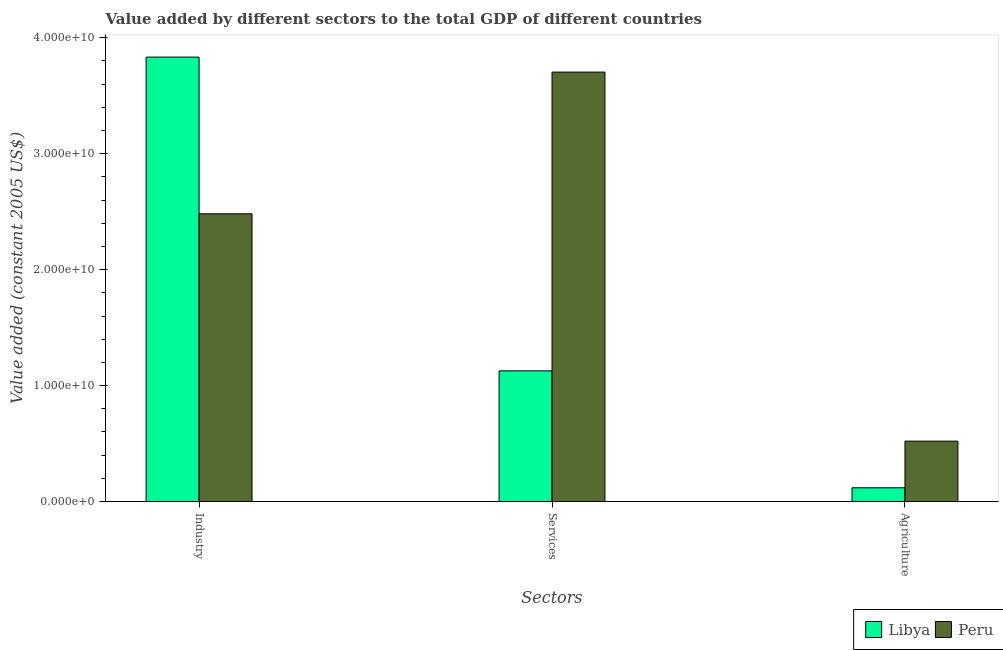Are the number of bars on each tick of the X-axis equal?
Offer a very short reply. Yes. How many bars are there on the 2nd tick from the left?
Ensure brevity in your answer.  2. How many bars are there on the 2nd tick from the right?
Provide a short and direct response. 2. What is the label of the 1st group of bars from the left?
Offer a terse response. Industry. What is the value added by industrial sector in Peru?
Your answer should be very brief. 2.48e+1. Across all countries, what is the maximum value added by agricultural sector?
Provide a succinct answer. 5.21e+09. Across all countries, what is the minimum value added by industrial sector?
Your answer should be very brief. 2.48e+1. In which country was the value added by agricultural sector minimum?
Ensure brevity in your answer.  Libya. What is the total value added by agricultural sector in the graph?
Give a very brief answer. 6.40e+09. What is the difference between the value added by services in Peru and that in Libya?
Provide a short and direct response. 2.58e+1. What is the difference between the value added by agricultural sector in Libya and the value added by services in Peru?
Make the answer very short. -3.58e+1. What is the average value added by services per country?
Make the answer very short. 2.42e+1. What is the difference between the value added by services and value added by agricultural sector in Peru?
Give a very brief answer. 3.18e+1. In how many countries, is the value added by industrial sector greater than 32000000000 US$?
Offer a very short reply. 1. What is the ratio of the value added by industrial sector in Peru to that in Libya?
Your response must be concise. 0.65. Is the value added by services in Libya less than that in Peru?
Offer a very short reply. Yes. What is the difference between the highest and the second highest value added by services?
Offer a terse response. 2.58e+1. What is the difference between the highest and the lowest value added by agricultural sector?
Your answer should be compact. 4.02e+09. Is the sum of the value added by agricultural sector in Peru and Libya greater than the maximum value added by services across all countries?
Provide a succinct answer. No. What does the 1st bar from the left in Services represents?
Offer a terse response. Libya. What does the 2nd bar from the right in Services represents?
Your answer should be very brief. Libya. Is it the case that in every country, the sum of the value added by industrial sector and value added by services is greater than the value added by agricultural sector?
Your answer should be compact. Yes. Are all the bars in the graph horizontal?
Offer a very short reply. No. Where does the legend appear in the graph?
Provide a short and direct response. Bottom right. How many legend labels are there?
Provide a succinct answer. 2. How are the legend labels stacked?
Your response must be concise. Horizontal. What is the title of the graph?
Your answer should be very brief. Value added by different sectors to the total GDP of different countries. What is the label or title of the X-axis?
Offer a terse response. Sectors. What is the label or title of the Y-axis?
Provide a succinct answer. Value added (constant 2005 US$). What is the Value added (constant 2005 US$) in Libya in Industry?
Give a very brief answer. 3.83e+1. What is the Value added (constant 2005 US$) of Peru in Industry?
Your response must be concise. 2.48e+1. What is the Value added (constant 2005 US$) of Libya in Services?
Ensure brevity in your answer.  1.13e+1. What is the Value added (constant 2005 US$) of Peru in Services?
Keep it short and to the point. 3.70e+1. What is the Value added (constant 2005 US$) of Libya in Agriculture?
Provide a short and direct response. 1.19e+09. What is the Value added (constant 2005 US$) of Peru in Agriculture?
Give a very brief answer. 5.21e+09. Across all Sectors, what is the maximum Value added (constant 2005 US$) in Libya?
Your response must be concise. 3.83e+1. Across all Sectors, what is the maximum Value added (constant 2005 US$) in Peru?
Keep it short and to the point. 3.70e+1. Across all Sectors, what is the minimum Value added (constant 2005 US$) of Libya?
Keep it short and to the point. 1.19e+09. Across all Sectors, what is the minimum Value added (constant 2005 US$) in Peru?
Provide a short and direct response. 5.21e+09. What is the total Value added (constant 2005 US$) of Libya in the graph?
Offer a very short reply. 5.08e+1. What is the total Value added (constant 2005 US$) in Peru in the graph?
Your response must be concise. 6.71e+1. What is the difference between the Value added (constant 2005 US$) in Libya in Industry and that in Services?
Ensure brevity in your answer.  2.71e+1. What is the difference between the Value added (constant 2005 US$) in Peru in Industry and that in Services?
Your response must be concise. -1.22e+1. What is the difference between the Value added (constant 2005 US$) of Libya in Industry and that in Agriculture?
Your response must be concise. 3.71e+1. What is the difference between the Value added (constant 2005 US$) of Peru in Industry and that in Agriculture?
Your answer should be very brief. 1.96e+1. What is the difference between the Value added (constant 2005 US$) of Libya in Services and that in Agriculture?
Your answer should be compact. 1.01e+1. What is the difference between the Value added (constant 2005 US$) in Peru in Services and that in Agriculture?
Your answer should be very brief. 3.18e+1. What is the difference between the Value added (constant 2005 US$) of Libya in Industry and the Value added (constant 2005 US$) of Peru in Services?
Give a very brief answer. 1.29e+09. What is the difference between the Value added (constant 2005 US$) in Libya in Industry and the Value added (constant 2005 US$) in Peru in Agriculture?
Your response must be concise. 3.31e+1. What is the difference between the Value added (constant 2005 US$) of Libya in Services and the Value added (constant 2005 US$) of Peru in Agriculture?
Your answer should be compact. 6.06e+09. What is the average Value added (constant 2005 US$) of Libya per Sectors?
Offer a terse response. 1.69e+1. What is the average Value added (constant 2005 US$) in Peru per Sectors?
Keep it short and to the point. 2.24e+1. What is the difference between the Value added (constant 2005 US$) of Libya and Value added (constant 2005 US$) of Peru in Industry?
Your answer should be very brief. 1.35e+1. What is the difference between the Value added (constant 2005 US$) in Libya and Value added (constant 2005 US$) in Peru in Services?
Provide a short and direct response. -2.58e+1. What is the difference between the Value added (constant 2005 US$) of Libya and Value added (constant 2005 US$) of Peru in Agriculture?
Offer a terse response. -4.02e+09. What is the ratio of the Value added (constant 2005 US$) in Libya in Industry to that in Services?
Provide a short and direct response. 3.4. What is the ratio of the Value added (constant 2005 US$) in Peru in Industry to that in Services?
Offer a very short reply. 0.67. What is the ratio of the Value added (constant 2005 US$) of Libya in Industry to that in Agriculture?
Your answer should be compact. 32.26. What is the ratio of the Value added (constant 2005 US$) of Peru in Industry to that in Agriculture?
Offer a terse response. 4.76. What is the ratio of the Value added (constant 2005 US$) in Libya in Services to that in Agriculture?
Your answer should be very brief. 9.49. What is the ratio of the Value added (constant 2005 US$) in Peru in Services to that in Agriculture?
Your answer should be very brief. 7.11. What is the difference between the highest and the second highest Value added (constant 2005 US$) in Libya?
Keep it short and to the point. 2.71e+1. What is the difference between the highest and the second highest Value added (constant 2005 US$) of Peru?
Provide a succinct answer. 1.22e+1. What is the difference between the highest and the lowest Value added (constant 2005 US$) of Libya?
Keep it short and to the point. 3.71e+1. What is the difference between the highest and the lowest Value added (constant 2005 US$) in Peru?
Provide a succinct answer. 3.18e+1. 